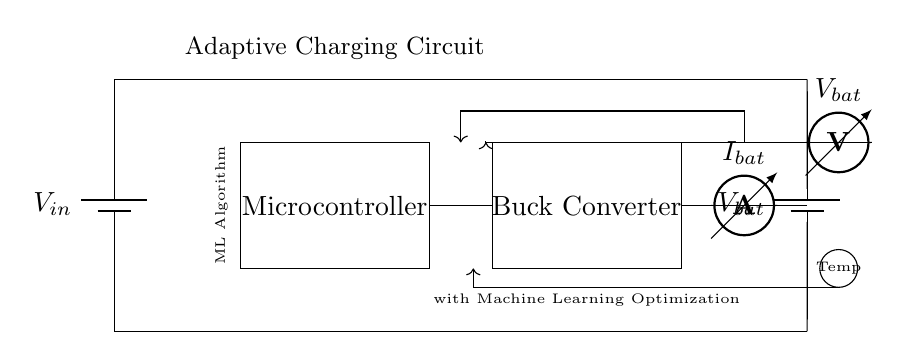what component is shown as the main power source? The main power source is a battery, labeled as V in, which provides the initial voltage to the circuit.
Answer: battery what does the microcontroller do in this circuit? The microcontroller processes data, implements the machine learning algorithm, and regulates the operation of the buck converter, helping to optimize charging efficiency.
Answer: optimize charging how is the current measured in the circuit? The current is measured using an ammeter, which is connected in series with the battery and labeled as I bat, indicating the current flowing through the battery.
Answer: ammeter what is the purpose of the buck converter? The buck converter is used to step down the voltage from the power source, ensuring that the battery receives a suitable charging voltage while maintaining efficiency.
Answer: step down voltage how does the circuit feedback mechanism work? The feedback mechanism works by using sensors to monitor battery voltage, current, and temperature, sending this information to the microcontroller to adjust the charging parameters dynamically for optimized performance.
Answer: dynamic adjustment 